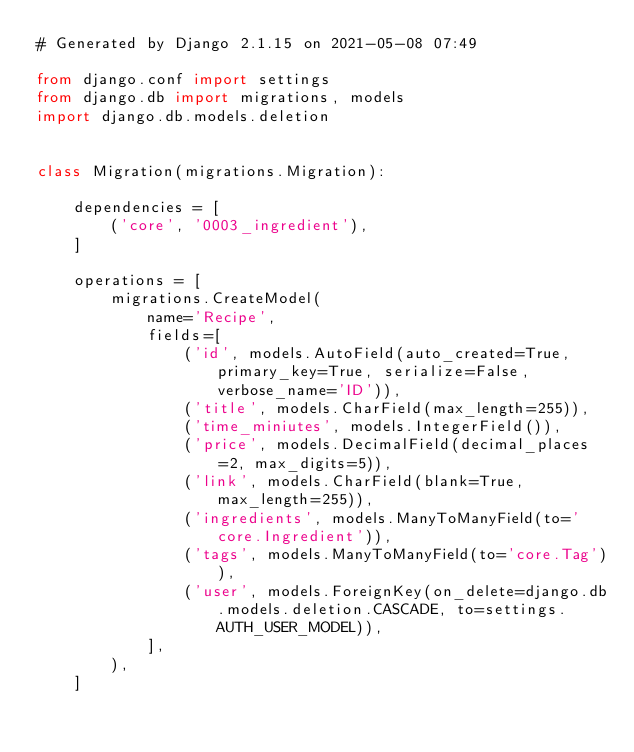<code> <loc_0><loc_0><loc_500><loc_500><_Python_># Generated by Django 2.1.15 on 2021-05-08 07:49

from django.conf import settings
from django.db import migrations, models
import django.db.models.deletion


class Migration(migrations.Migration):

    dependencies = [
        ('core', '0003_ingredient'),
    ]

    operations = [
        migrations.CreateModel(
            name='Recipe',
            fields=[
                ('id', models.AutoField(auto_created=True, primary_key=True, serialize=False, verbose_name='ID')),
                ('title', models.CharField(max_length=255)),
                ('time_miniutes', models.IntegerField()),
                ('price', models.DecimalField(decimal_places=2, max_digits=5)),
                ('link', models.CharField(blank=True, max_length=255)),
                ('ingredients', models.ManyToManyField(to='core.Ingredient')),
                ('tags', models.ManyToManyField(to='core.Tag')),
                ('user', models.ForeignKey(on_delete=django.db.models.deletion.CASCADE, to=settings.AUTH_USER_MODEL)),
            ],
        ),
    ]
</code> 